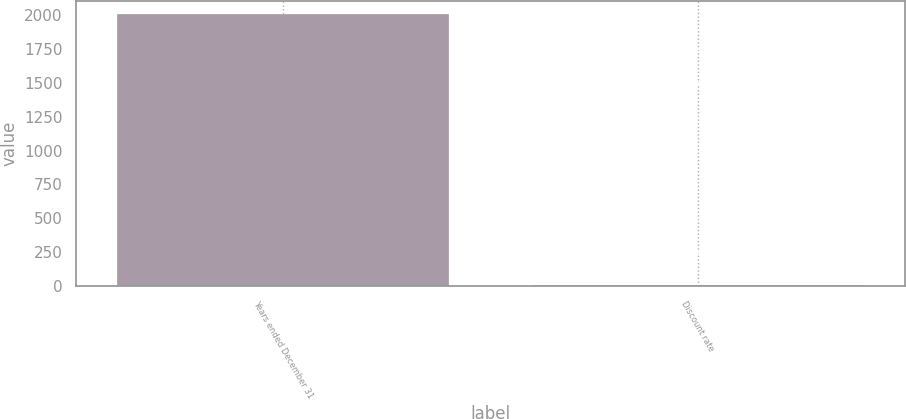<chart> <loc_0><loc_0><loc_500><loc_500><bar_chart><fcel>Years ended December 31<fcel>Discount rate<nl><fcel>2008<fcel>5.31<nl></chart> 